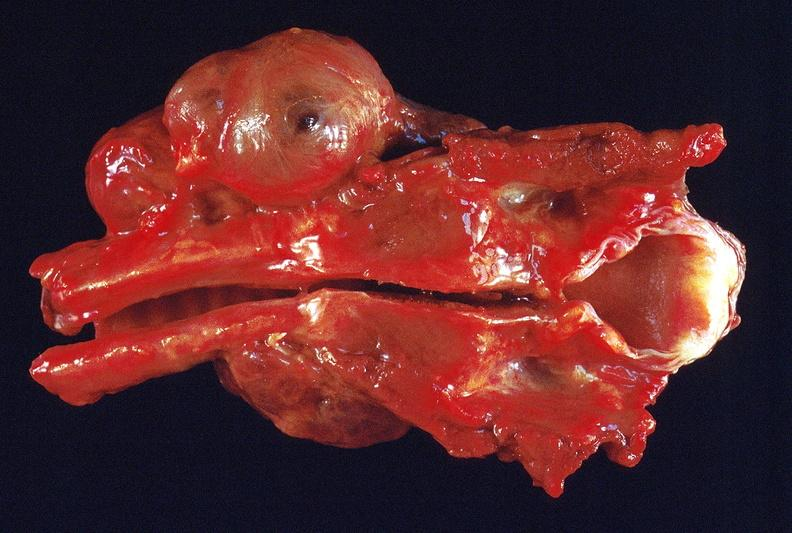what is present?
Answer the question using a single word or phrase. Endocrine 